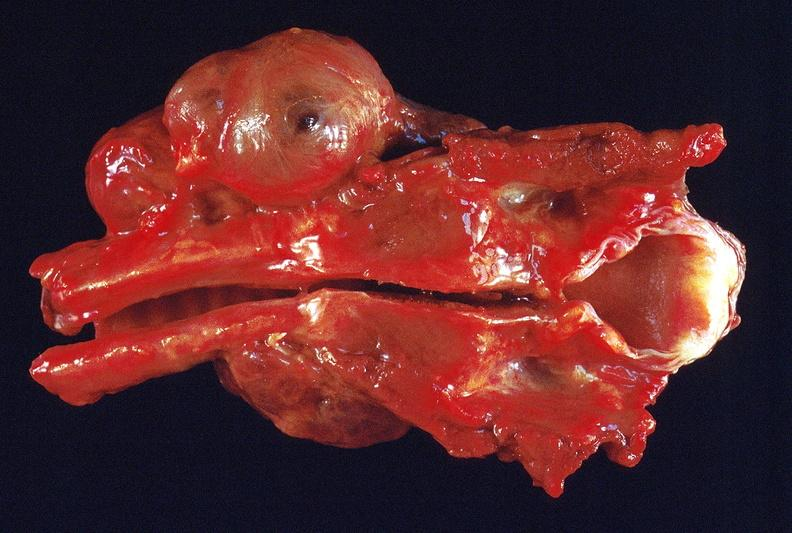what is present?
Answer the question using a single word or phrase. Endocrine 